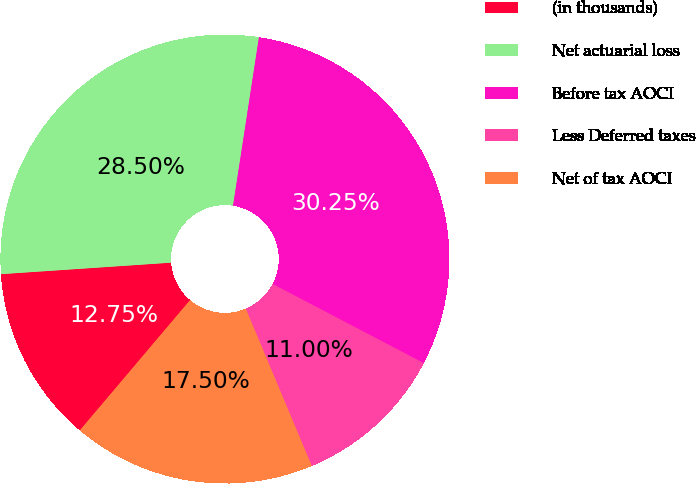<chart> <loc_0><loc_0><loc_500><loc_500><pie_chart><fcel>(in thousands)<fcel>Net actuarial loss<fcel>Before tax AOCI<fcel>Less Deferred taxes<fcel>Net of tax AOCI<nl><fcel>12.75%<fcel>28.5%<fcel>30.25%<fcel>11.0%<fcel>17.5%<nl></chart> 